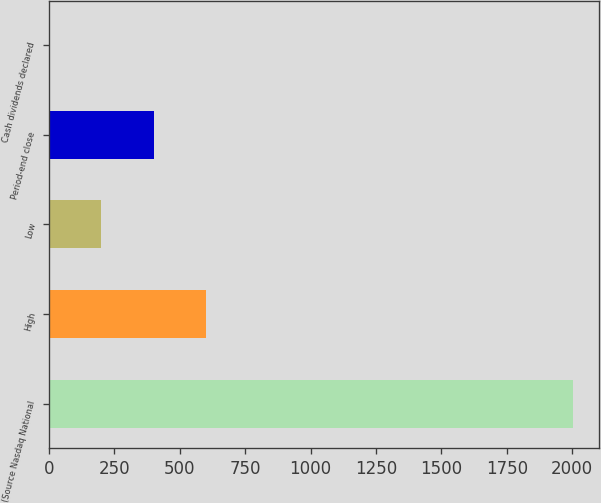Convert chart. <chart><loc_0><loc_0><loc_500><loc_500><bar_chart><fcel>(Source Nasdaq National<fcel>High<fcel>Low<fcel>Period-end close<fcel>Cash dividends declared<nl><fcel>2004<fcel>601.38<fcel>200.62<fcel>401<fcel>0.25<nl></chart> 